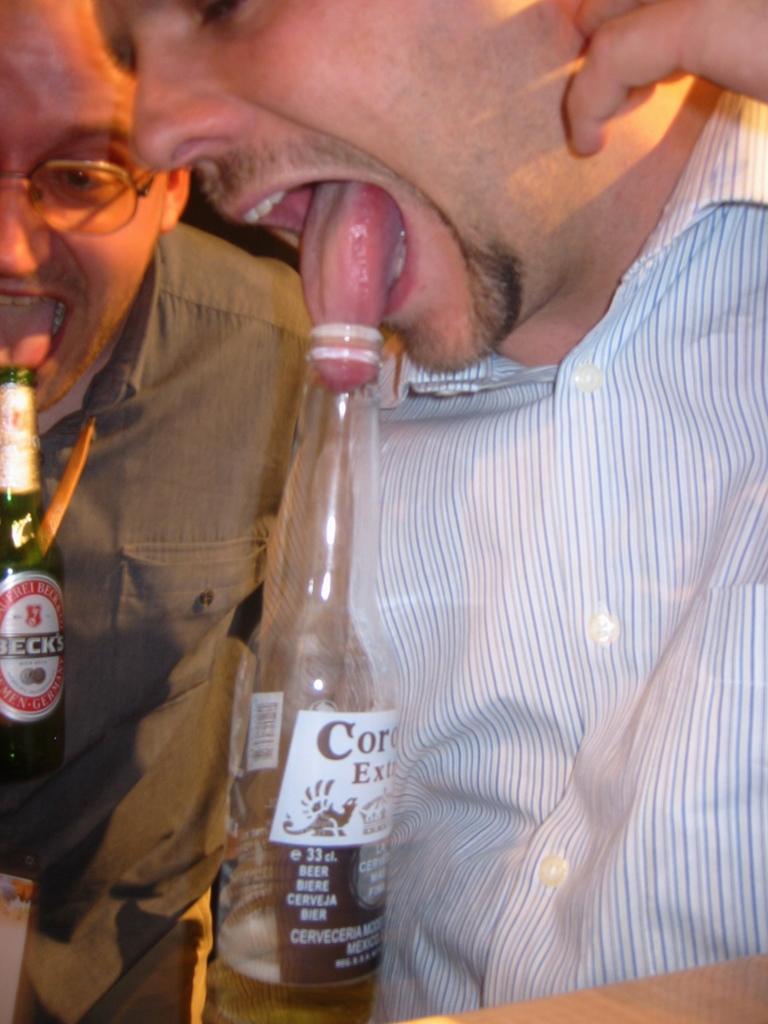Can you describe this image briefly? Here there is a man he is inserting his tongue into the bottle and also he is wearing a shirt beside of him there is another man who is trying to insert the tongue into the bottle. 